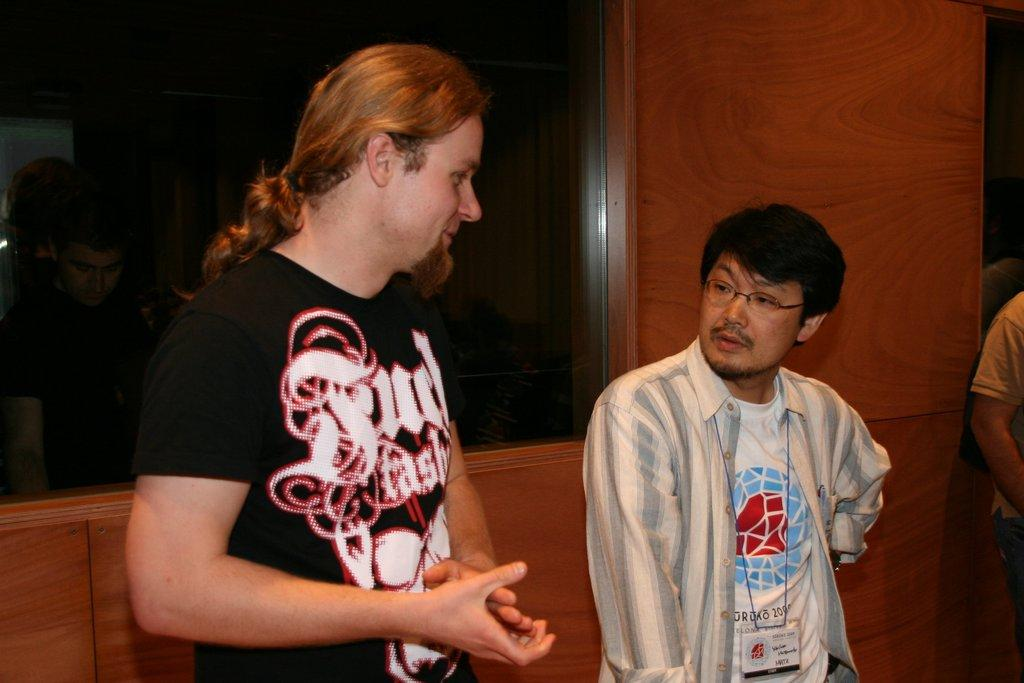How many people are in the image? There is a group of people in the image. Can you describe any specific details about one of the people? One person is wearing an ID card. What can be seen in the background of the image? There is a window and a wall in the background of the image. What type of bread is being served at the airport in the image? There is no mention of bread or an airport in the image; it features a group of people and a background with a window and a wall. 